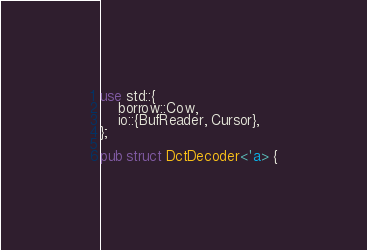Convert code to text. <code><loc_0><loc_0><loc_500><loc_500><_Rust_>use std::{
    borrow::Cow,
    io::{BufReader, Cursor},
};

pub struct DctDecoder<'a> {</code> 